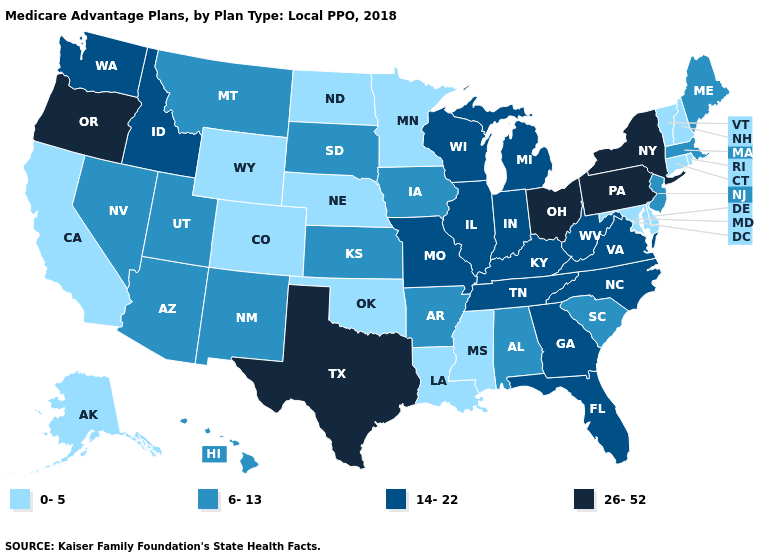What is the value of Ohio?
Keep it brief. 26-52. What is the value of Iowa?
Concise answer only. 6-13. Does Texas have the highest value in the USA?
Give a very brief answer. Yes. Does Ohio have the highest value in the USA?
Write a very short answer. Yes. What is the highest value in the USA?
Concise answer only. 26-52. Does Michigan have the highest value in the MidWest?
Answer briefly. No. Does Mississippi have the lowest value in the South?
Keep it brief. Yes. Among the states that border Florida , which have the highest value?
Be succinct. Georgia. What is the highest value in the West ?
Answer briefly. 26-52. How many symbols are there in the legend?
Keep it brief. 4. Which states have the highest value in the USA?
Be succinct. New York, Ohio, Oregon, Pennsylvania, Texas. Among the states that border Wyoming , does Colorado have the lowest value?
Short answer required. Yes. Name the states that have a value in the range 14-22?
Answer briefly. Florida, Georgia, Idaho, Illinois, Indiana, Kentucky, Michigan, Missouri, North Carolina, Tennessee, Virginia, Washington, Wisconsin, West Virginia. Name the states that have a value in the range 26-52?
Be succinct. New York, Ohio, Oregon, Pennsylvania, Texas. 